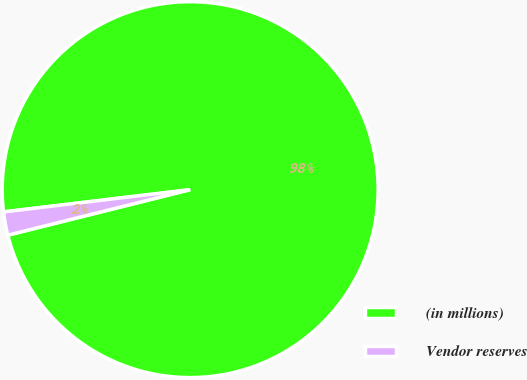Convert chart. <chart><loc_0><loc_0><loc_500><loc_500><pie_chart><fcel>(in millions)<fcel>Vendor reserves<nl><fcel>98.0%<fcel>2.0%<nl></chart> 